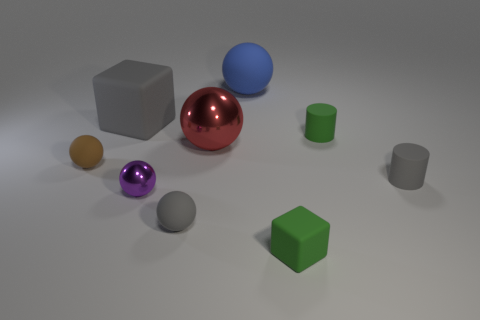How many spheres are visible in the image, and which one would you say is the most striking? There are three spheres in this image. The most striking one could be considered the red sphere, given its vibrant color and reflective surface that catches the light, drawing immediate attention. 